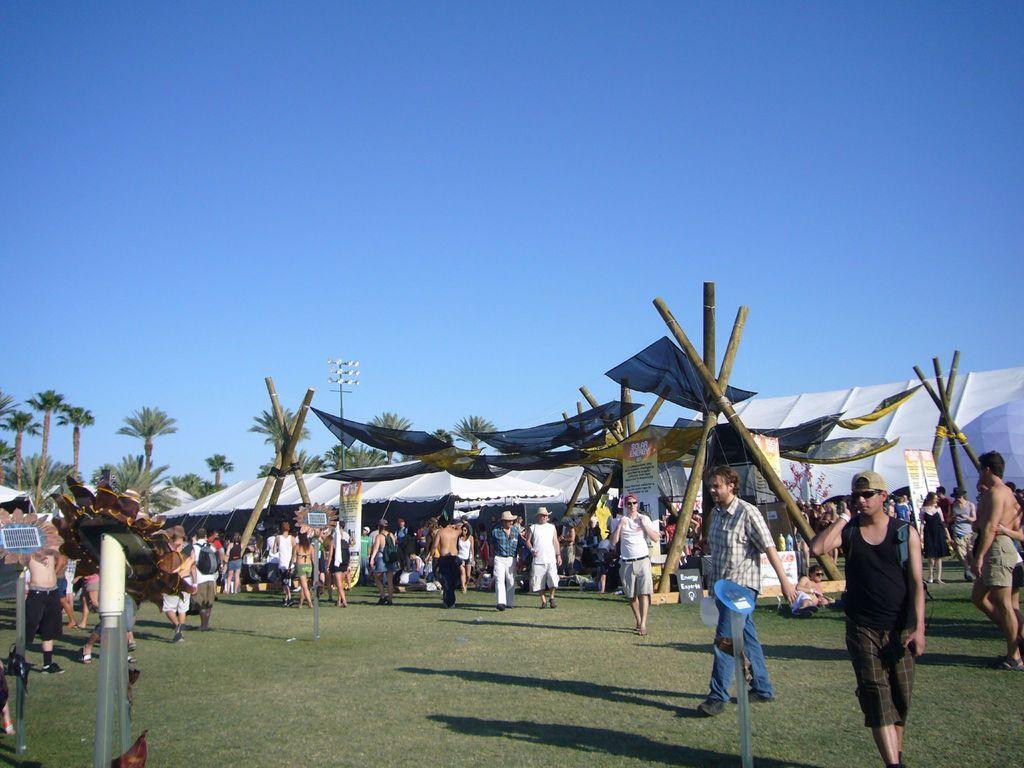Describe this image in one or two sentences. In this picture, we see people walking on the ground. Behind them, we see white color tents and poles. In the left bottom of the picture, we see a pole. We even see banners with some text written on it. There are trees and a pole in the background. At the top of the picture, we see the sky, which is blue in color. 